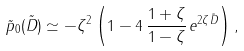Convert formula to latex. <formula><loc_0><loc_0><loc_500><loc_500>\tilde { p } _ { 0 } ( \tilde { D } ) \simeq - \zeta ^ { 2 } \left ( 1 - 4 \, \frac { 1 + \zeta } { 1 - \zeta } \, e ^ { 2 \zeta \tilde { D } } \right ) ,</formula> 